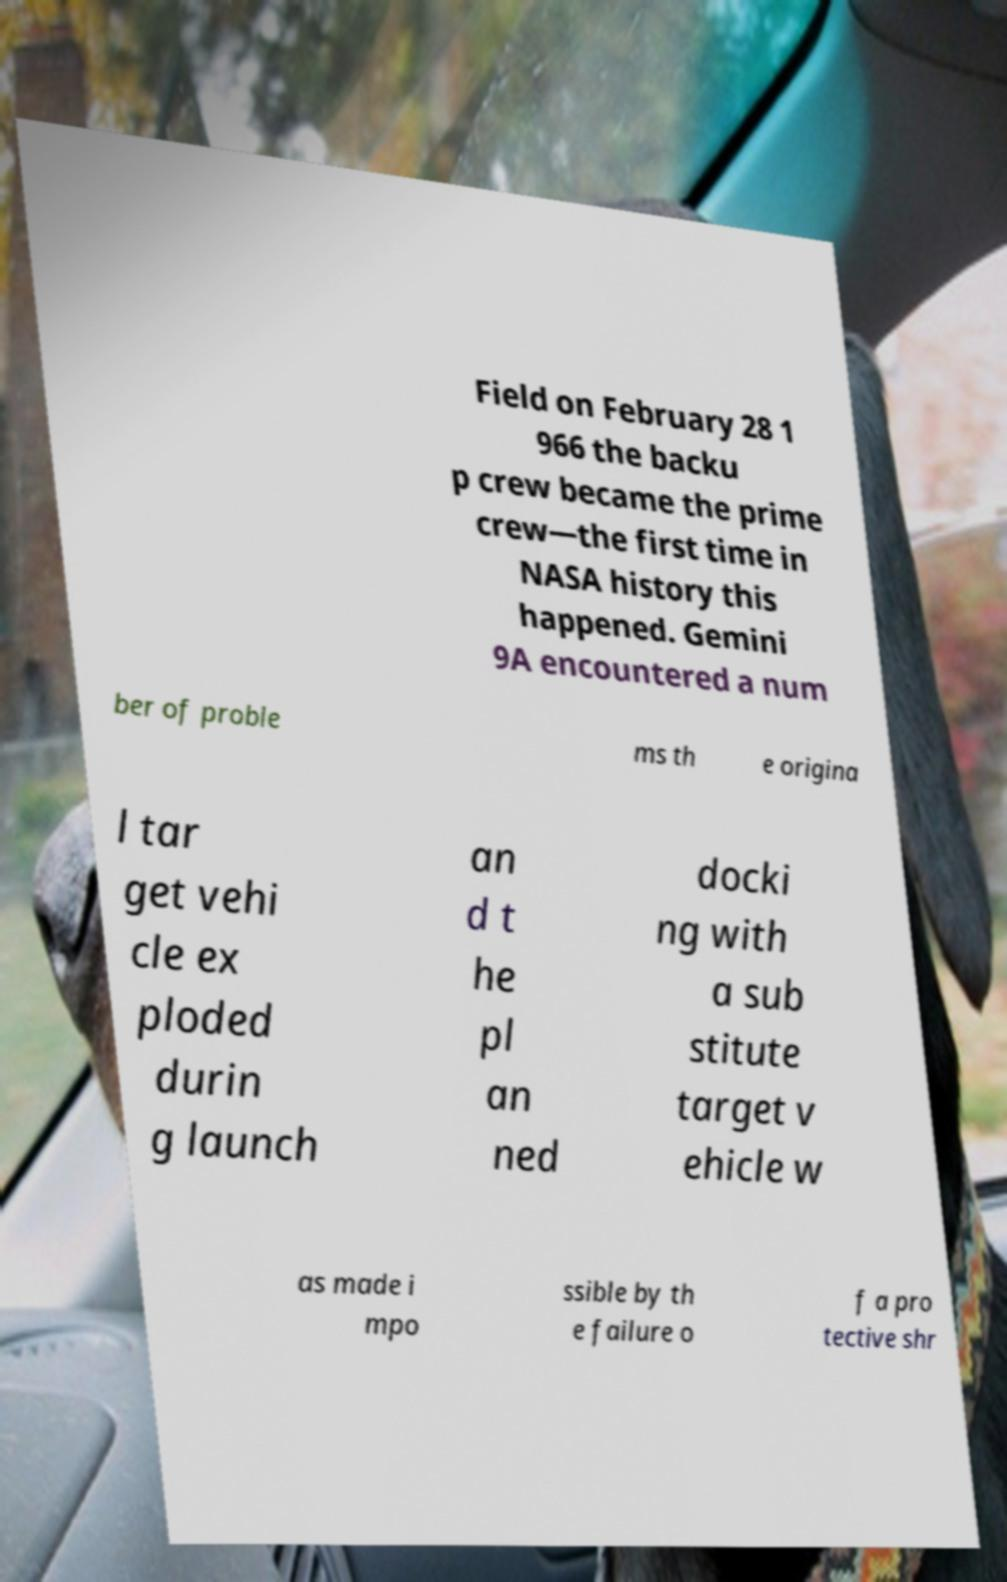Can you accurately transcribe the text from the provided image for me? Field on February 28 1 966 the backu p crew became the prime crew—the first time in NASA history this happened. Gemini 9A encountered a num ber of proble ms th e origina l tar get vehi cle ex ploded durin g launch an d t he pl an ned docki ng with a sub stitute target v ehicle w as made i mpo ssible by th e failure o f a pro tective shr 